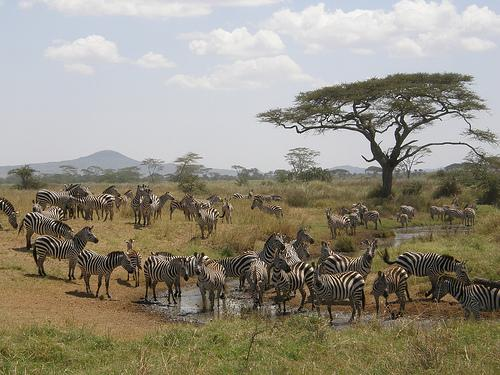Write a brief report-style explanation of the image. The image captures an instance of wild zebras at a gathering point, showcasing multiple individuals engaged in various activities, such as drinking and eating, against a backdrop of trees, mountains, and cloudy skies. Provide a brief summary of the scene in the image. In the image, numerous zebras mingle near a water source surrounded by trees and mountains, with cloudy skies overhead. Relate the contents of the image from the perspective of a curious observer. I came across a bustling gathering of zebras near a small creek, peacefully drinking and grazing, while towering trees and mountains stood proudly behind them. Explain the image focusing on the environment and wildlife interaction. In a vibrant ecosystem, a herd of zebras quench their thirst and graze on grass, surrounded by the beauty of trees, mountains, and a cloudy sky. Express the contents and mood of the image in a poetic manner. Where the mountain meets the sky, zebras roam and thrive, beneath a veil of clouds, beside a muddy creek, the plains become alive. Mention the primary focus of the image and their activity. A zeal of zebras is gathered at a watering hole, some are drinking water and others are grazing on grass in the African plains. Present an amusing description of the image. A zebra party is in full swing at a popular watering hole, complete with tail wagging, grass munching, and head-to-head socializing! Describe the setting and actions of the subjects in the image. The image captures a busy watering hole in the African plains, where zebras drink, eat grass and interact with each other. List down the prominent elements and events occurring in the image. Zebras gathered, watering hole, tree, mountain, green grass, clouds in the sky, zebras drinking and eating. Narrate the image as if you were telling a story. Once upon a time, in the vast African plains, a herd of zebras convened at their favorite watering hole, where they drank, ate, and celebrated life under a sky peppered with clouds. 